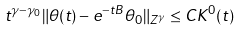Convert formula to latex. <formula><loc_0><loc_0><loc_500><loc_500>t ^ { \gamma - \gamma _ { 0 } } \| \theta ( t ) - e ^ { - t B } \theta _ { 0 } \| _ { Z ^ { \gamma } } \leq C K ^ { 0 } ( t )</formula> 